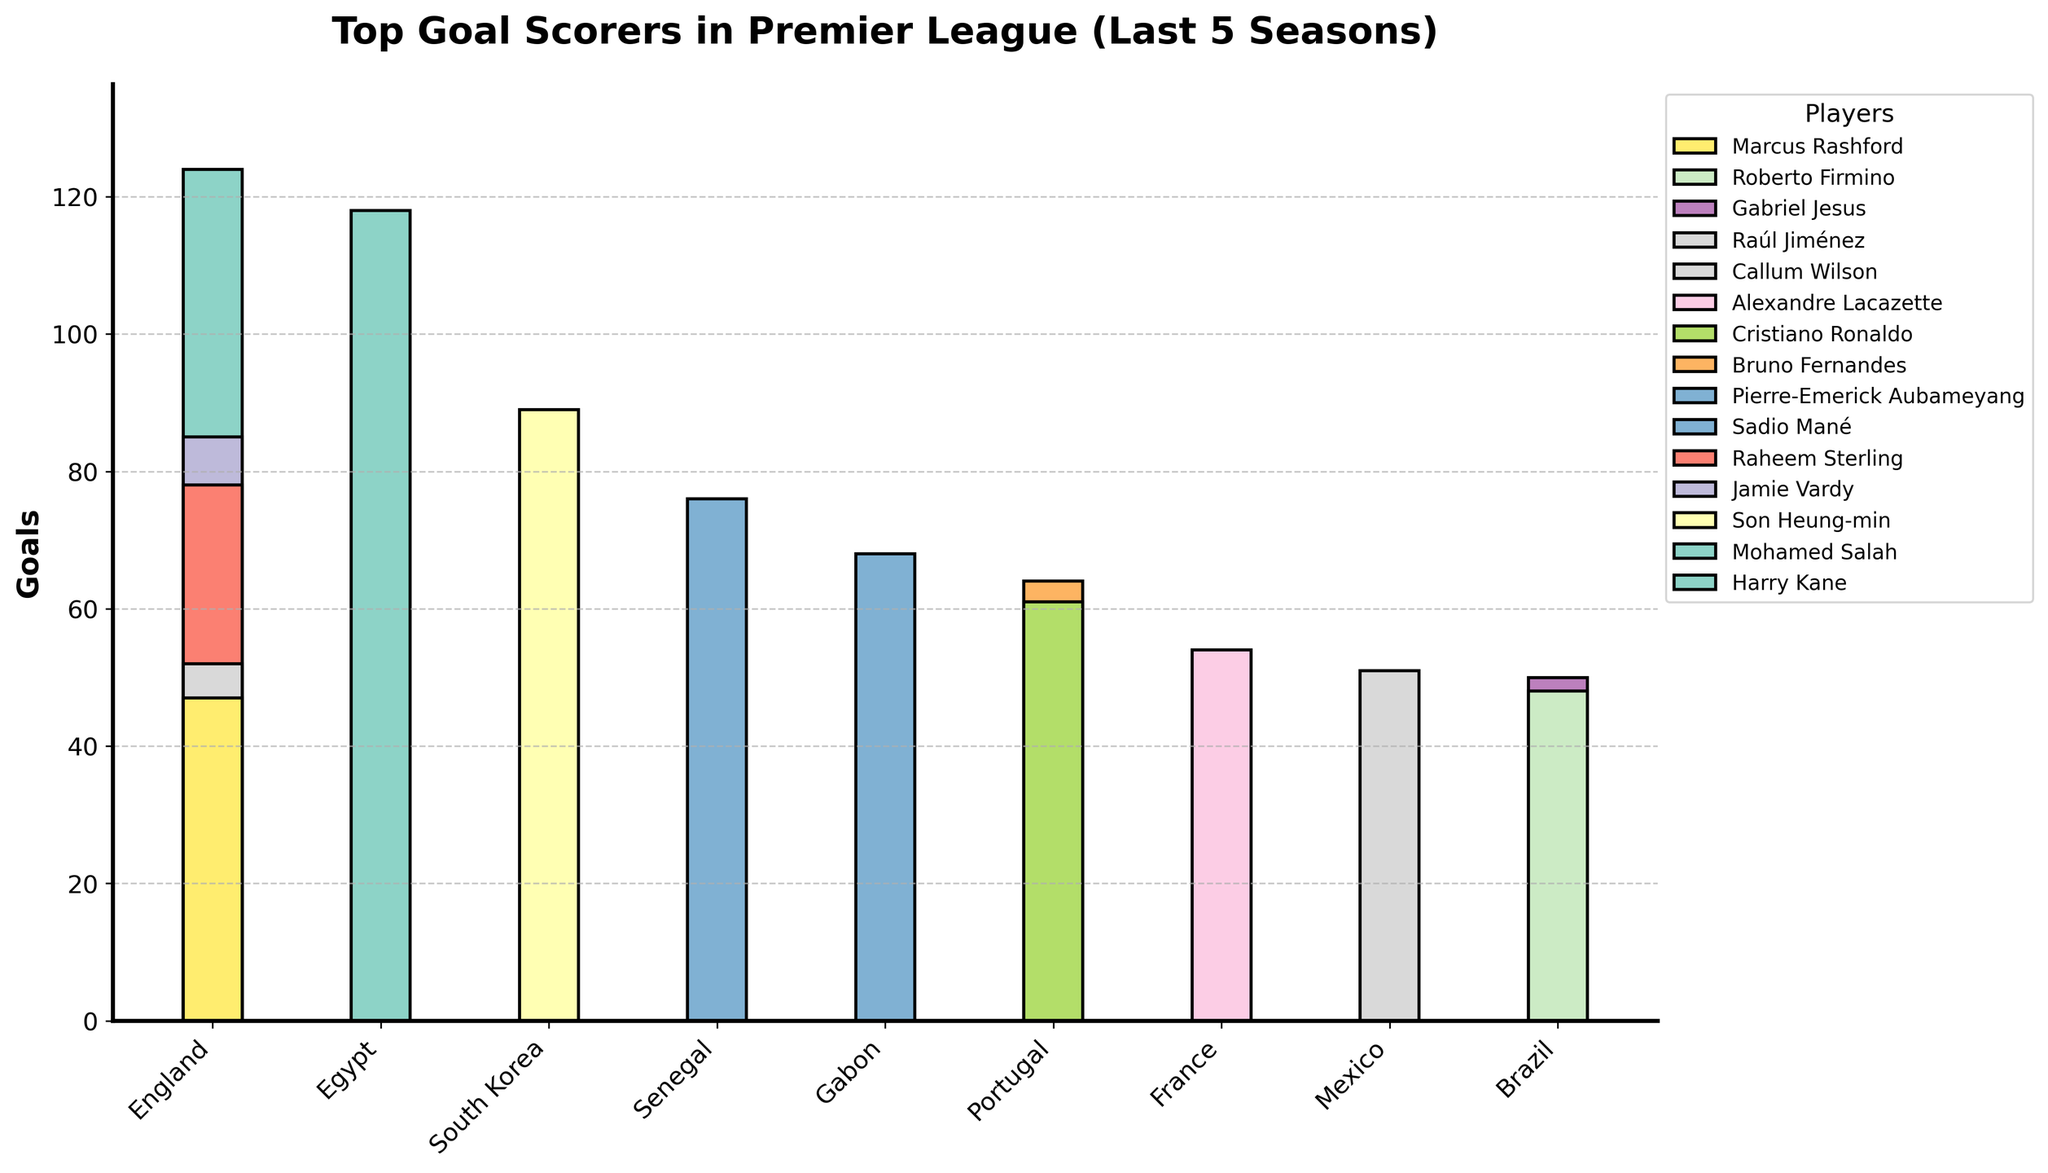How many English players are among the top goal scorers? By looking at the nationality labels and counting the English players, we identify: Harry Kane, Jamie Vardy, Raheem Sterling, Callum Wilson, and Marcus Rashford.
Answer: 5 Which player scored the most goals in the Premier League over the last 5 seasons? By examining the height of the bars and checking the corresponding names in the legend, Harry Kane has the tallest bar indicating the highest number of goals.
Answer: Harry Kane What is the total number of goals scored by players from Brazil? Adding the goals of Brazilian players: Gabriel Jesus (50) and Roberto Firmino (48). So, 50 + 48 = 98.
Answer: 98 Who scored more goals, Son Heung-min or Raheem Sterling? By comparing the bars for Son Heung-min and Raheem Sterling, Son Heung-min's bar is taller.
Answer: Son Heung-min What is the difference in goals between the top scorer and the second highest scorer? The top scorer is Harry Kane with 124 goals, and the second highest is Mohamed Salah with 118 goals. The difference is 124 - 118 = 6 goals.
Answer: 6 Which nationality has the most players among the top goal scorers? By counting the number of players for each nationality: England (5 players) has the most.
Answer: England How many goals were scored by the player from South Korea? By locating South Korea in the x-axis and checking the associated bar's height, Son Heung-min scored 89 goals.
Answer: 89 Is the number of goals scored by Marcus Rashford greater than the combined goals of Raúl Jiménez and Alexandre Lacazette? Rashford scored 47 goals, Raúl Jiménez scored 51, and Alexandre Lacazette scored 54. Combined, Jiménez and Lacazette scored 51 + 54 = 105 goals, which is greater than Rashford's 47 goals.
Answer: No Compare the total goals scored by English players to that of Portuguese players. Which group has more goals? Summing goals for English players (Harry Kane 124, Jamie Vardy 85, Raheem Sterling 78, Callum Wilson 52, Marcus Rashford 47) totals 386. Portuguese players (Bruno Fernandes 64, Cristiano Ronaldo 61) total 125. English players scored more.
Answer: English players What is the average number of goals scored by the top 3 goal scorers? Summing goals of top 3: Harry Kane (124), Mohamed Salah (118), Son Heung-min (89). Total is 124 + 118 + 89 = 331. Dividing by 3 gives 331 / 3 ≈ 110.33.
Answer: 110.33 